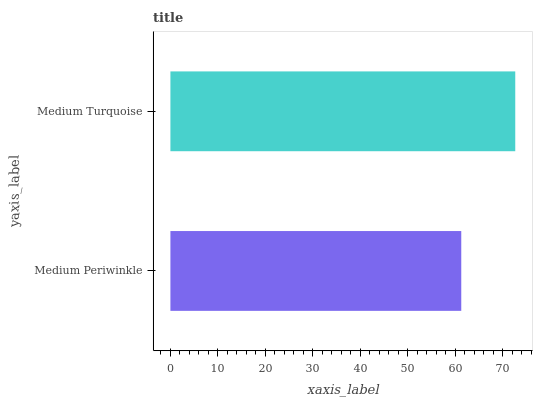Is Medium Periwinkle the minimum?
Answer yes or no. Yes. Is Medium Turquoise the maximum?
Answer yes or no. Yes. Is Medium Turquoise the minimum?
Answer yes or no. No. Is Medium Turquoise greater than Medium Periwinkle?
Answer yes or no. Yes. Is Medium Periwinkle less than Medium Turquoise?
Answer yes or no. Yes. Is Medium Periwinkle greater than Medium Turquoise?
Answer yes or no. No. Is Medium Turquoise less than Medium Periwinkle?
Answer yes or no. No. Is Medium Turquoise the high median?
Answer yes or no. Yes. Is Medium Periwinkle the low median?
Answer yes or no. Yes. Is Medium Periwinkle the high median?
Answer yes or no. No. Is Medium Turquoise the low median?
Answer yes or no. No. 